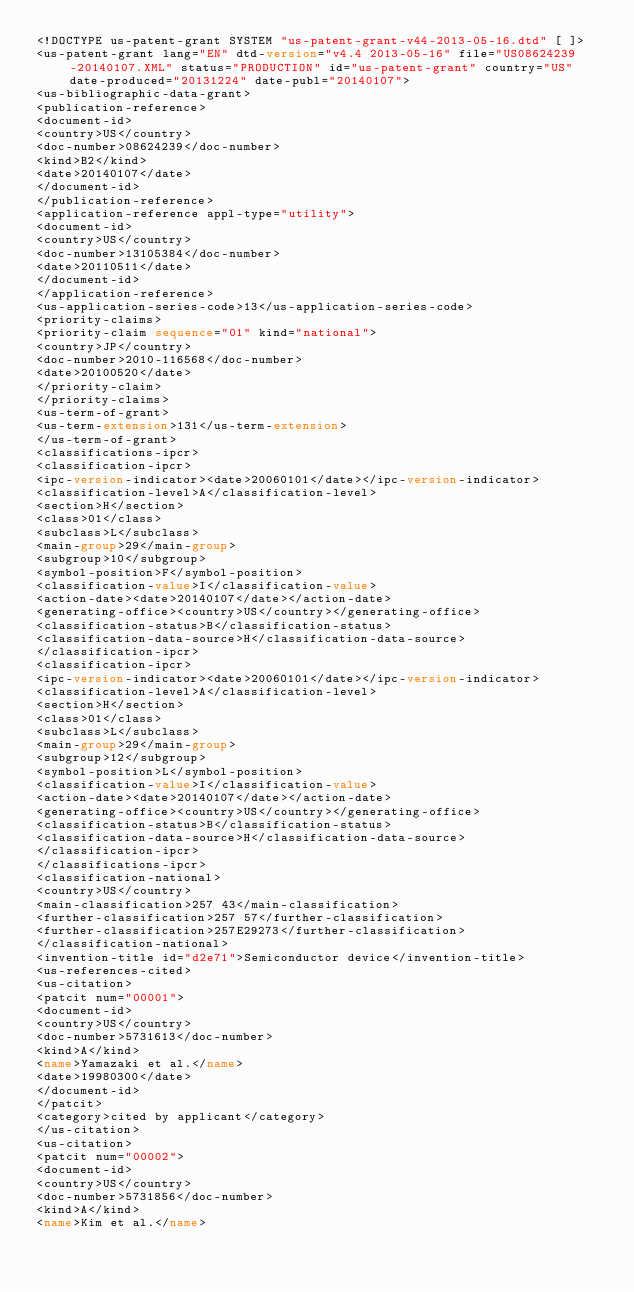<code> <loc_0><loc_0><loc_500><loc_500><_XML_><!DOCTYPE us-patent-grant SYSTEM "us-patent-grant-v44-2013-05-16.dtd" [ ]>
<us-patent-grant lang="EN" dtd-version="v4.4 2013-05-16" file="US08624239-20140107.XML" status="PRODUCTION" id="us-patent-grant" country="US" date-produced="20131224" date-publ="20140107">
<us-bibliographic-data-grant>
<publication-reference>
<document-id>
<country>US</country>
<doc-number>08624239</doc-number>
<kind>B2</kind>
<date>20140107</date>
</document-id>
</publication-reference>
<application-reference appl-type="utility">
<document-id>
<country>US</country>
<doc-number>13105384</doc-number>
<date>20110511</date>
</document-id>
</application-reference>
<us-application-series-code>13</us-application-series-code>
<priority-claims>
<priority-claim sequence="01" kind="national">
<country>JP</country>
<doc-number>2010-116568</doc-number>
<date>20100520</date>
</priority-claim>
</priority-claims>
<us-term-of-grant>
<us-term-extension>131</us-term-extension>
</us-term-of-grant>
<classifications-ipcr>
<classification-ipcr>
<ipc-version-indicator><date>20060101</date></ipc-version-indicator>
<classification-level>A</classification-level>
<section>H</section>
<class>01</class>
<subclass>L</subclass>
<main-group>29</main-group>
<subgroup>10</subgroup>
<symbol-position>F</symbol-position>
<classification-value>I</classification-value>
<action-date><date>20140107</date></action-date>
<generating-office><country>US</country></generating-office>
<classification-status>B</classification-status>
<classification-data-source>H</classification-data-source>
</classification-ipcr>
<classification-ipcr>
<ipc-version-indicator><date>20060101</date></ipc-version-indicator>
<classification-level>A</classification-level>
<section>H</section>
<class>01</class>
<subclass>L</subclass>
<main-group>29</main-group>
<subgroup>12</subgroup>
<symbol-position>L</symbol-position>
<classification-value>I</classification-value>
<action-date><date>20140107</date></action-date>
<generating-office><country>US</country></generating-office>
<classification-status>B</classification-status>
<classification-data-source>H</classification-data-source>
</classification-ipcr>
</classifications-ipcr>
<classification-national>
<country>US</country>
<main-classification>257 43</main-classification>
<further-classification>257 57</further-classification>
<further-classification>257E29273</further-classification>
</classification-national>
<invention-title id="d2e71">Semiconductor device</invention-title>
<us-references-cited>
<us-citation>
<patcit num="00001">
<document-id>
<country>US</country>
<doc-number>5731613</doc-number>
<kind>A</kind>
<name>Yamazaki et al.</name>
<date>19980300</date>
</document-id>
</patcit>
<category>cited by applicant</category>
</us-citation>
<us-citation>
<patcit num="00002">
<document-id>
<country>US</country>
<doc-number>5731856</doc-number>
<kind>A</kind>
<name>Kim et al.</name></code> 